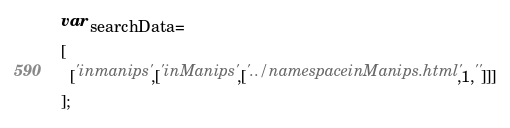Convert code to text. <code><loc_0><loc_0><loc_500><loc_500><_JavaScript_>var searchData=
[
  ['inmanips',['inManips',['../namespaceinManips.html',1,'']]]
];
</code> 